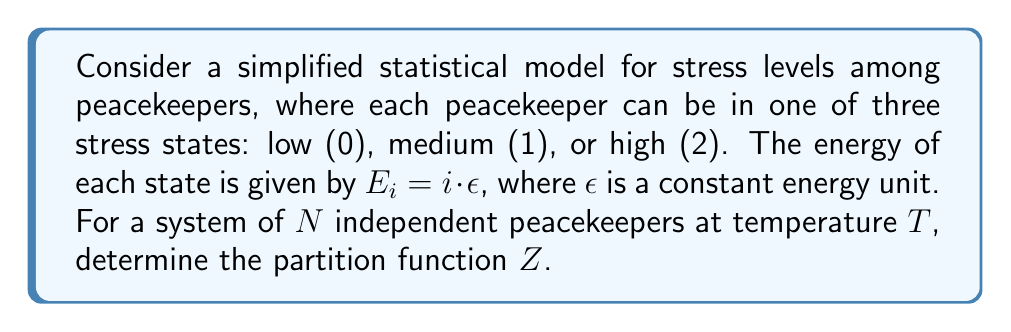Teach me how to tackle this problem. To solve this problem, we'll follow these steps:

1) The partition function $Z$ for a system of $N$ independent particles is given by:

   $$Z = (z_{single})^N$$

   where $z_{single}$ is the partition function for a single particle.

2) For a single peacekeeper, the partition function is:

   $$z_{single} = \sum_i e^{-\beta E_i}$$

   where $\beta = \frac{1}{k_B T}$, $k_B$ is the Boltzmann constant, and $T$ is the temperature.

3) In our case, we have three states with energies $0$, $\epsilon$, and $2\epsilon$. So:

   $$z_{single} = e^{-\beta \cdot 0} + e^{-\beta \epsilon} + e^{-\beta \cdot 2\epsilon}$$

4) Simplify:

   $$z_{single} = 1 + e^{-\beta \epsilon} + e^{-2\beta \epsilon}$$

5) Now, for the system of $N$ peacekeepers:

   $$Z = (1 + e^{-\beta \epsilon} + e^{-2\beta \epsilon})^N$$

6) We can simplify this by defining $x = e^{-\beta \epsilon}$:

   $$Z = (1 + x + x^2)^N$$

This is the final form of the partition function for our system.
Answer: $Z = (1 + e^{-\beta \epsilon} + e^{-2\beta \epsilon})^N$ 